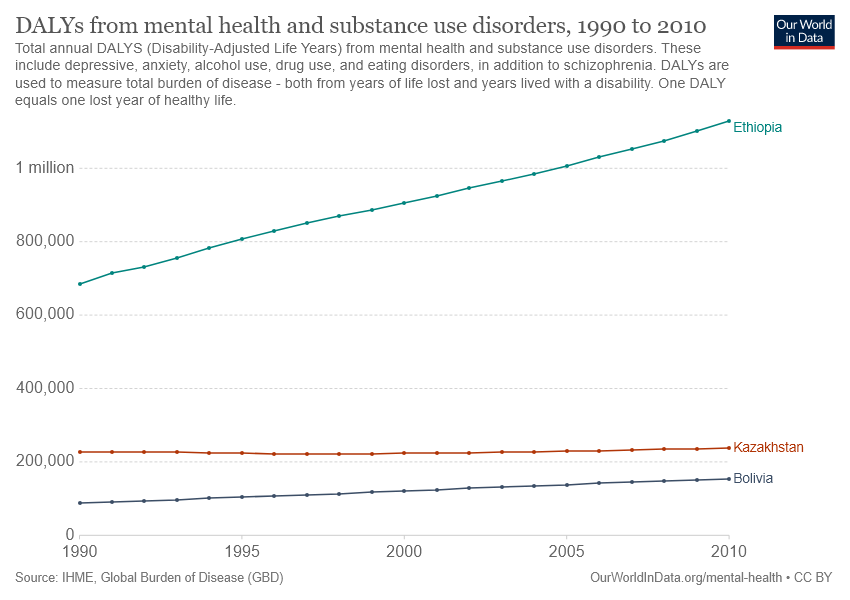Highlight a few significant elements in this photo. The highest burden of disease from mental health and substance use disorders in Ethiopia was in 2010, according to data. According to the data, Ethiopia has experienced the highest increase in disability-adjusted life years (DALYs) due to mental health and substance use disorders compared to other countries. 